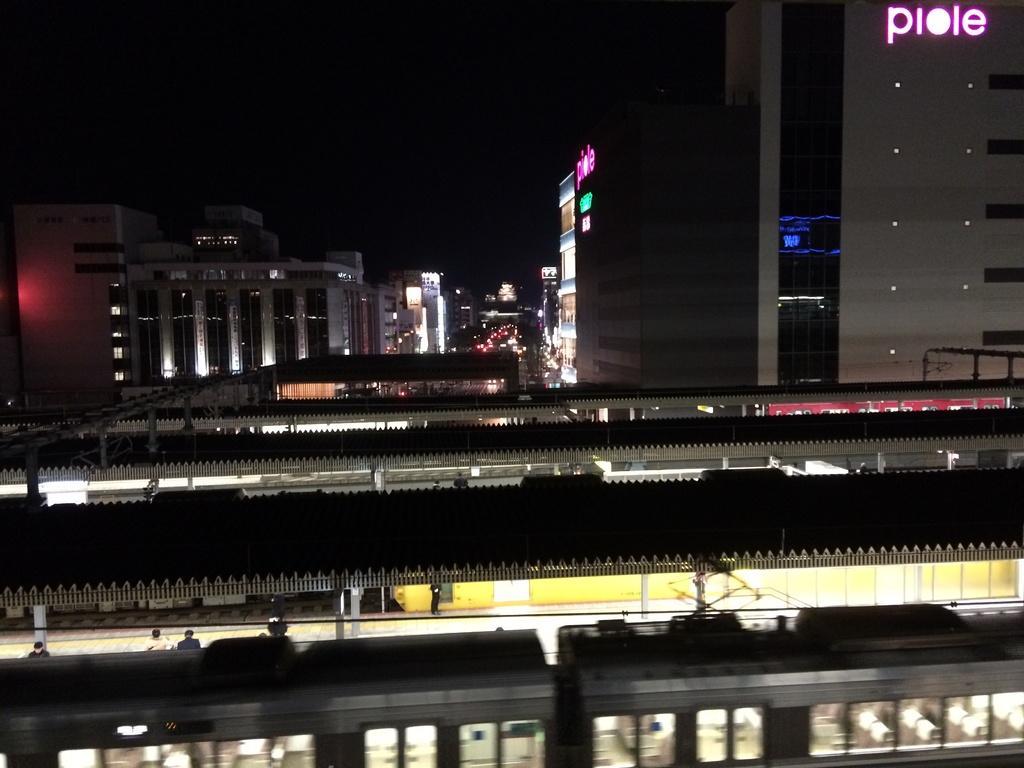Could you give a brief overview of what you see in this image? In this picture we can see a train, shelters, buildings, lights, some objects and some people and in the background it is dark. 